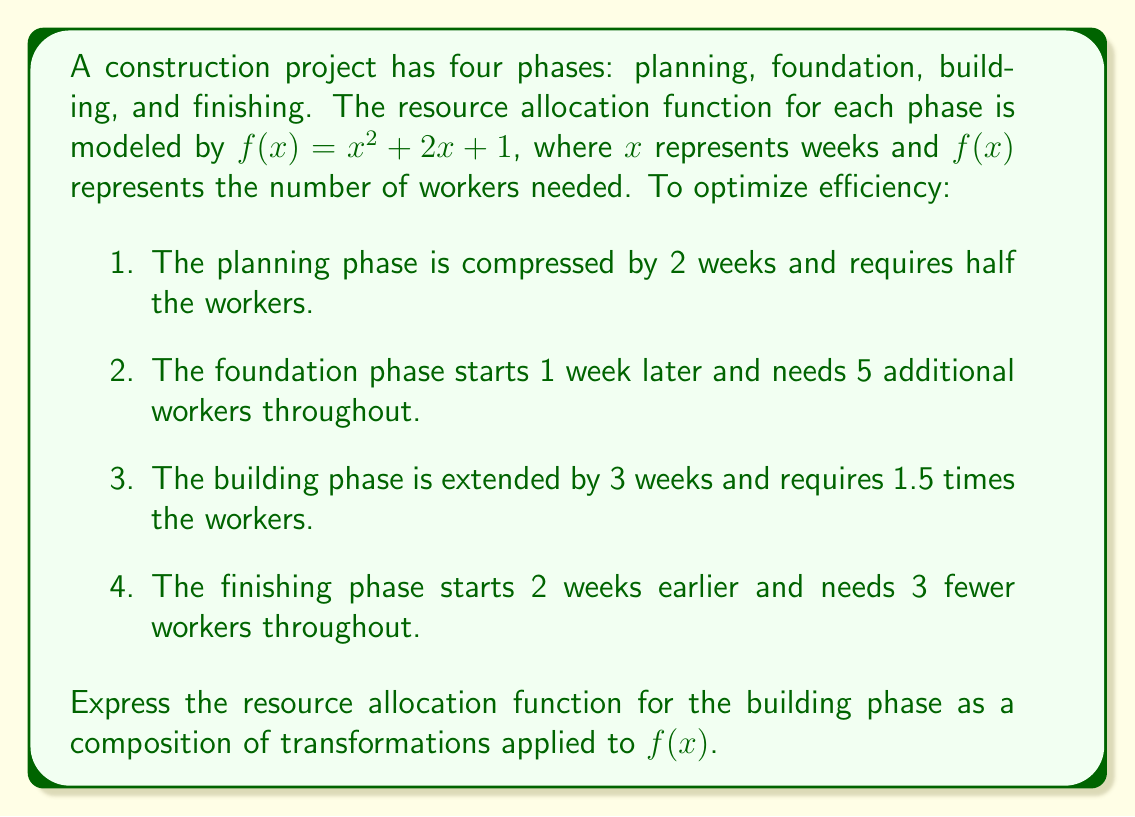What is the answer to this math problem? To solve this problem, we need to apply multiple transformations to the original function $f(x) = x^2 + 2x + 1$ based on the requirements for the building phase. Let's break it down step by step:

1. The building phase is extended by 3 weeks. This means we need to shift the function 3 units left:
   $f(x+3)$

2. The phase requires 1.5 times the workers. This is a vertical stretch by a factor of 1.5:
   $1.5f(x+3)$

Now, let's compose these transformations:

$$g(x) = 1.5f(x+3)$$

Substituting the original function:

$$g(x) = 1.5((x+3)^2 + 2(x+3) + 1)$$

Expanding the expression:

$$g(x) = 1.5(x^2 + 6x + 9 + 2x + 6 + 1)$$
$$g(x) = 1.5(x^2 + 8x + 16)$$

Distributing the 1.5:

$$g(x) = 1.5x^2 + 12x + 24$$

This is the final transformed function representing the resource allocation for the building phase.
Answer: $g(x) = 1.5x^2 + 12x + 24$ 